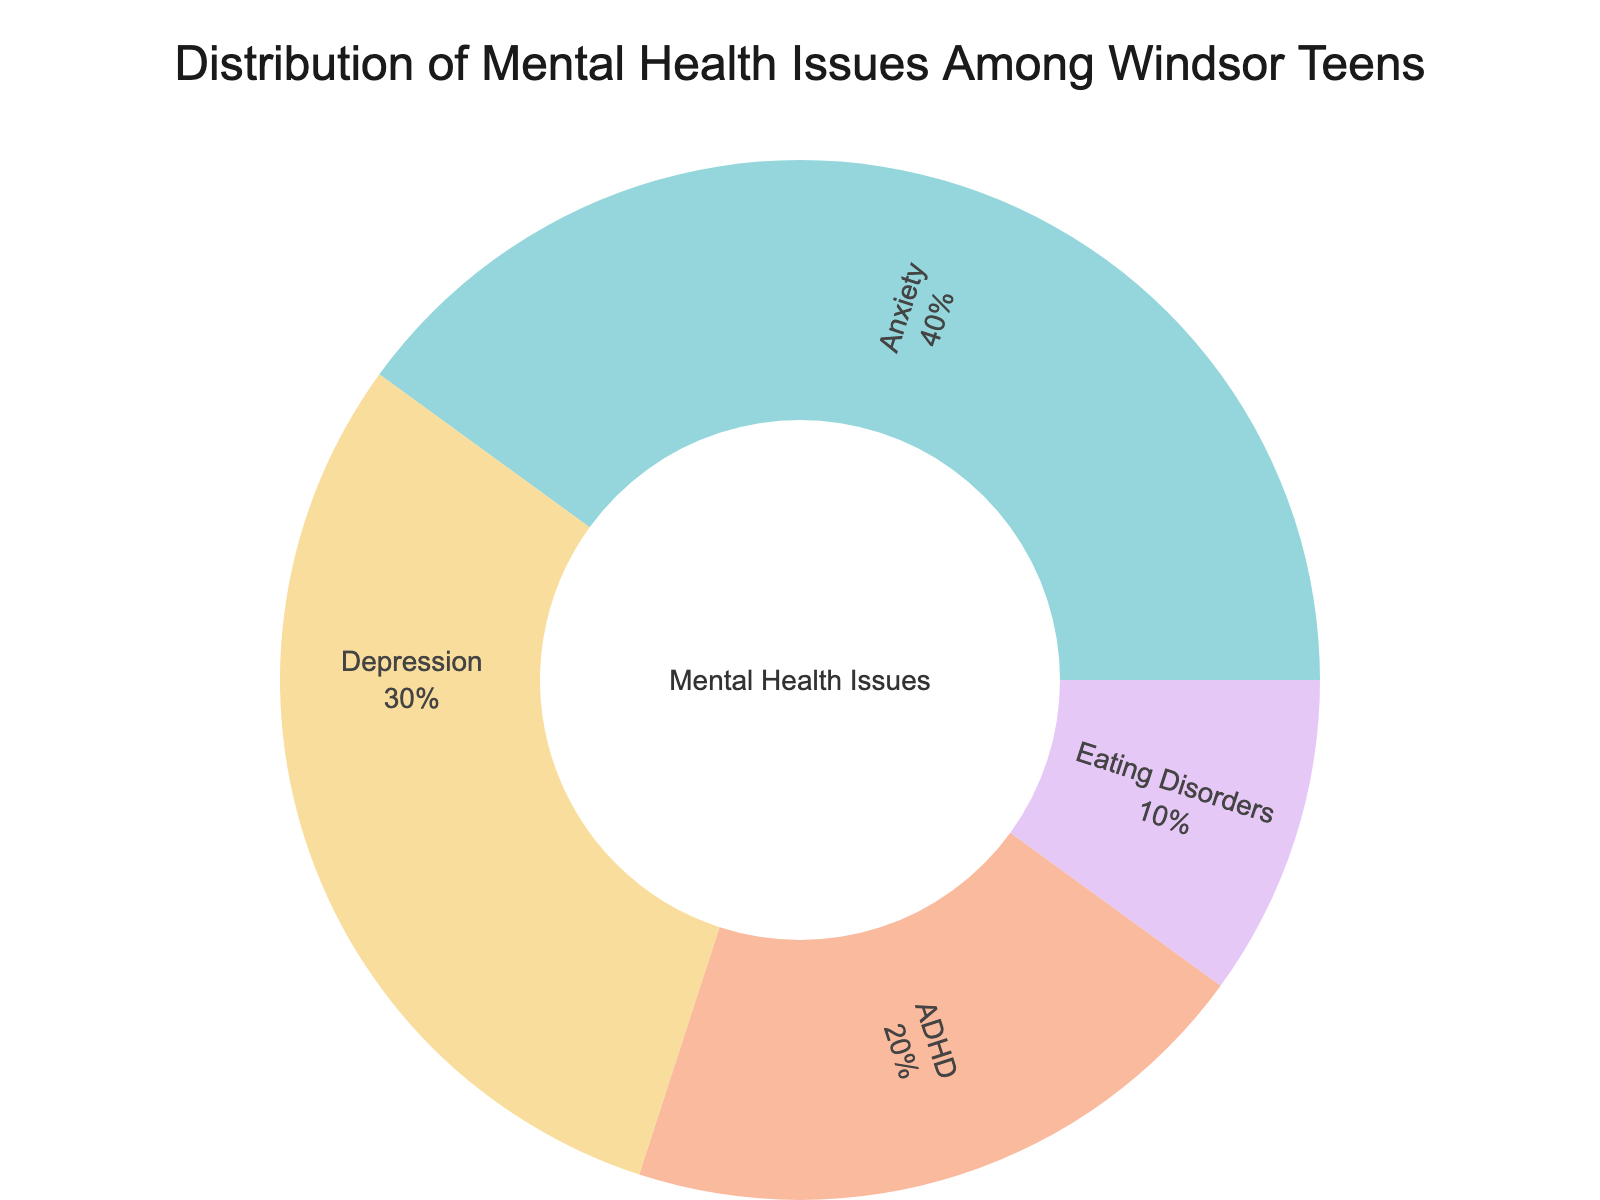What is the title of the sunburst plot? The title is written at the top center of the plot.
Answer: Distribution of Mental Health Issues Among Windsor Teens Which mental health issue has the highest value? The largest segment in the sunburst plot corresponds to the highest value.
Answer: Anxiety What percentage of the total do Eating Disorders make up? The percentage is written inside the segment for Eating Disorders in the sunburst chart.
Answer: 10% How do the values for Anxiety and ADHD compare? Compare the sizes of the segments in the sunburst plot. Anxiety's segment is larger than ADHD's.
Answer: Anxiety > ADHD What is the combined value of Anxiety and Depression? Find the values for Anxiety and Depression and add them: 40 (Anxiety) + 30 (Depression).
Answer: 70 Which mental health issue has the smallest value? The smallest segment in the sunburst plot represents the smallest value.
Answer: Eating Disorders What percentage of the total do Anxiety and Depression together constitute? Sum the values of Anxiety (40) and Depression (30) to get 70 and divide by the total value (100). Then multiply by 100 to get the percentage: (70/100) * 100%.
Answer: 70% Is Depression more common than ADHD according to the plot? Compare the sizes of the segments for Depression and ADHD.
Answer: Yes What is the difference in values between ADHD and Eating Disorders? Subtract the value of Eating Disorders (10) from ADHD (20): 20 - 10.
Answer: 10 What is the total value represented in the sunburst plot? Sum all the segment values: 40 (Anxiety) + 30 (Depression) + 20 (ADHD) + 10 (Eating Disorders).
Answer: 100 